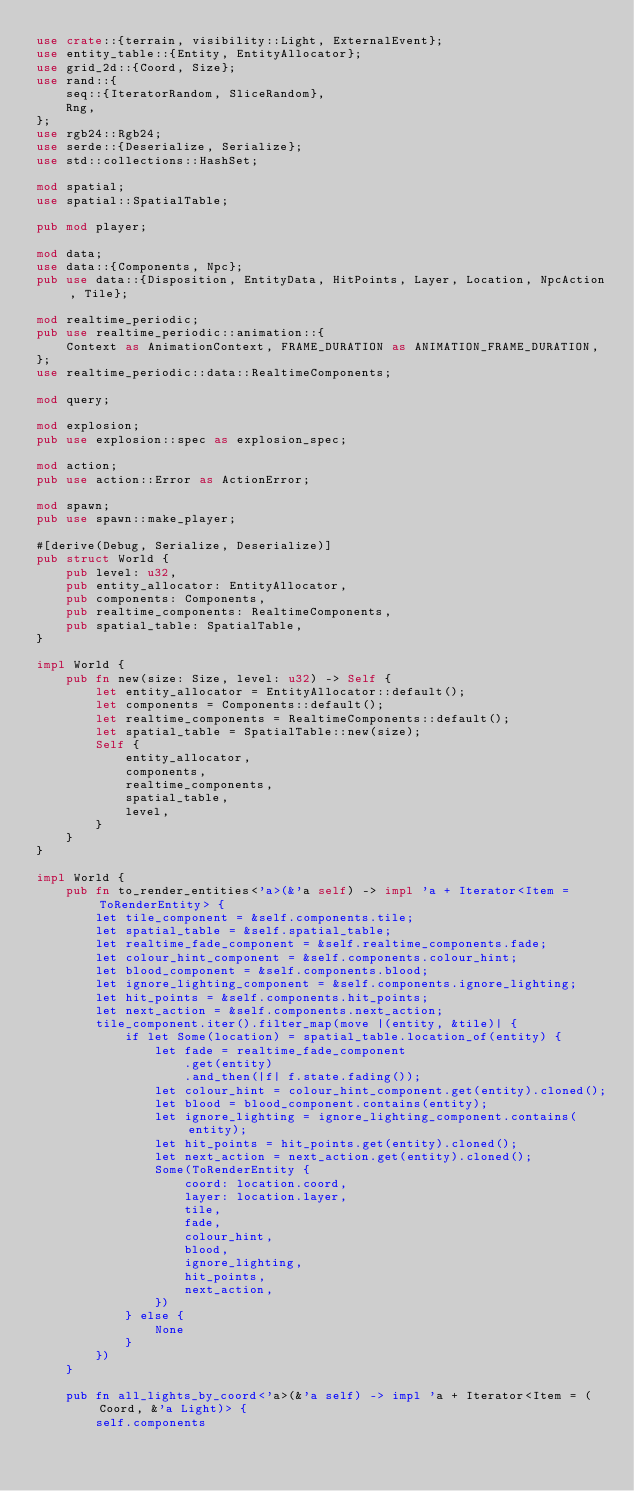<code> <loc_0><loc_0><loc_500><loc_500><_Rust_>use crate::{terrain, visibility::Light, ExternalEvent};
use entity_table::{Entity, EntityAllocator};
use grid_2d::{Coord, Size};
use rand::{
    seq::{IteratorRandom, SliceRandom},
    Rng,
};
use rgb24::Rgb24;
use serde::{Deserialize, Serialize};
use std::collections::HashSet;

mod spatial;
use spatial::SpatialTable;

pub mod player;

mod data;
use data::{Components, Npc};
pub use data::{Disposition, EntityData, HitPoints, Layer, Location, NpcAction, Tile};

mod realtime_periodic;
pub use realtime_periodic::animation::{
    Context as AnimationContext, FRAME_DURATION as ANIMATION_FRAME_DURATION,
};
use realtime_periodic::data::RealtimeComponents;

mod query;

mod explosion;
pub use explosion::spec as explosion_spec;

mod action;
pub use action::Error as ActionError;

mod spawn;
pub use spawn::make_player;

#[derive(Debug, Serialize, Deserialize)]
pub struct World {
    pub level: u32,
    pub entity_allocator: EntityAllocator,
    pub components: Components,
    pub realtime_components: RealtimeComponents,
    pub spatial_table: SpatialTable,
}

impl World {
    pub fn new(size: Size, level: u32) -> Self {
        let entity_allocator = EntityAllocator::default();
        let components = Components::default();
        let realtime_components = RealtimeComponents::default();
        let spatial_table = SpatialTable::new(size);
        Self {
            entity_allocator,
            components,
            realtime_components,
            spatial_table,
            level,
        }
    }
}

impl World {
    pub fn to_render_entities<'a>(&'a self) -> impl 'a + Iterator<Item = ToRenderEntity> {
        let tile_component = &self.components.tile;
        let spatial_table = &self.spatial_table;
        let realtime_fade_component = &self.realtime_components.fade;
        let colour_hint_component = &self.components.colour_hint;
        let blood_component = &self.components.blood;
        let ignore_lighting_component = &self.components.ignore_lighting;
        let hit_points = &self.components.hit_points;
        let next_action = &self.components.next_action;
        tile_component.iter().filter_map(move |(entity, &tile)| {
            if let Some(location) = spatial_table.location_of(entity) {
                let fade = realtime_fade_component
                    .get(entity)
                    .and_then(|f| f.state.fading());
                let colour_hint = colour_hint_component.get(entity).cloned();
                let blood = blood_component.contains(entity);
                let ignore_lighting = ignore_lighting_component.contains(entity);
                let hit_points = hit_points.get(entity).cloned();
                let next_action = next_action.get(entity).cloned();
                Some(ToRenderEntity {
                    coord: location.coord,
                    layer: location.layer,
                    tile,
                    fade,
                    colour_hint,
                    blood,
                    ignore_lighting,
                    hit_points,
                    next_action,
                })
            } else {
                None
            }
        })
    }

    pub fn all_lights_by_coord<'a>(&'a self) -> impl 'a + Iterator<Item = (Coord, &'a Light)> {
        self.components</code> 